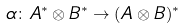Convert formula to latex. <formula><loc_0><loc_0><loc_500><loc_500>\alpha & \colon A ^ { * } \otimes B ^ { * } \rightarrow ( A \otimes B ) ^ { * }</formula> 